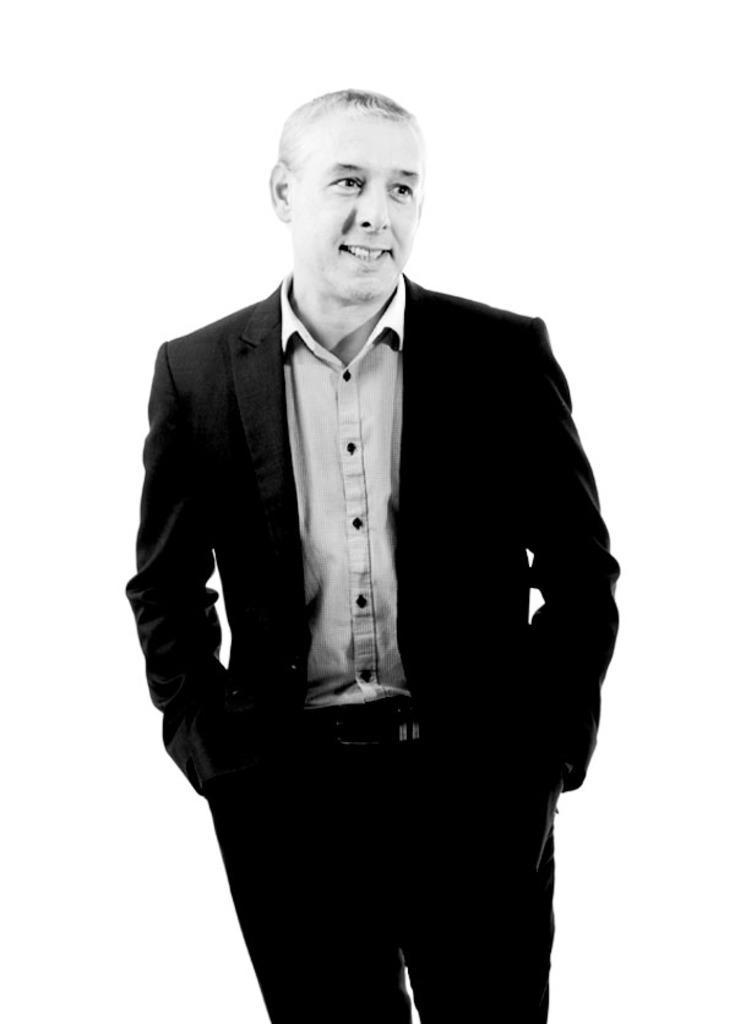Describe this image in one or two sentences. In this image we can see a man. He is wearing a suit. The background is white in color. 